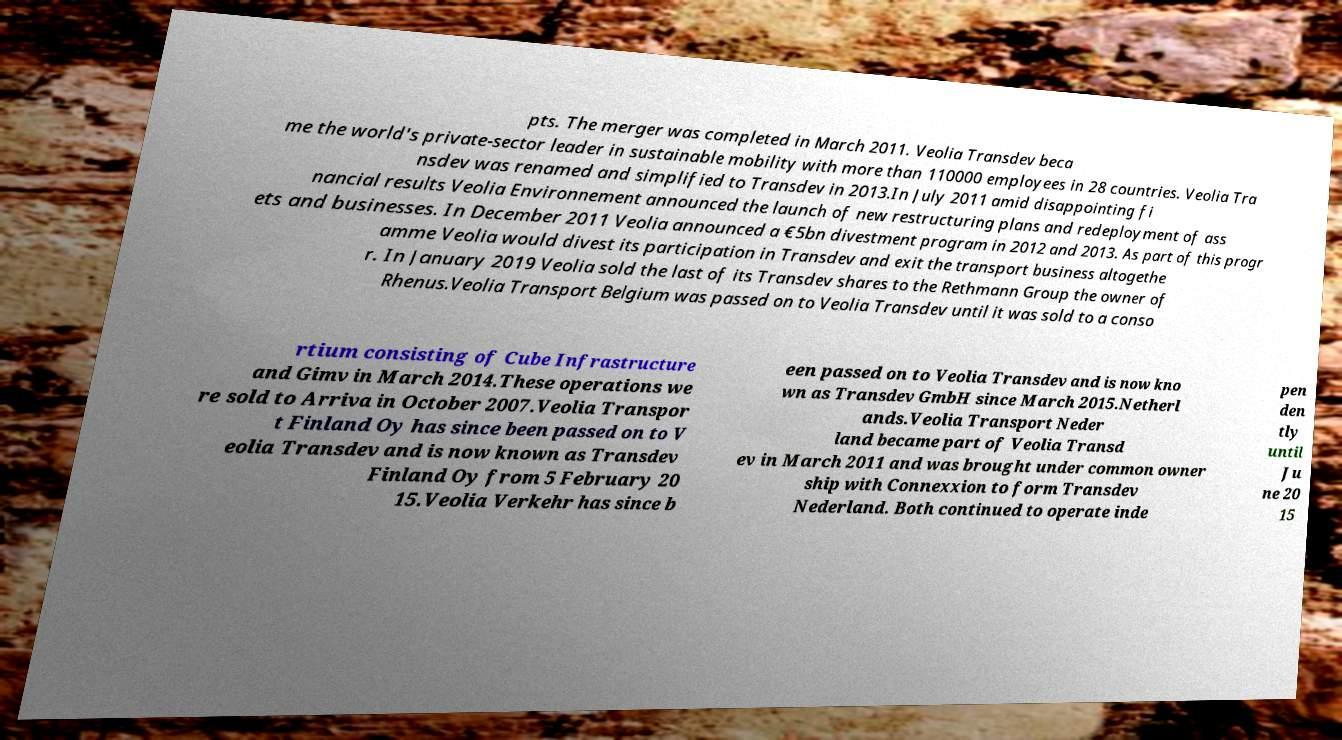Can you accurately transcribe the text from the provided image for me? pts. The merger was completed in March 2011. Veolia Transdev beca me the world's private-sector leader in sustainable mobility with more than 110000 employees in 28 countries. Veolia Tra nsdev was renamed and simplified to Transdev in 2013.In July 2011 amid disappointing fi nancial results Veolia Environnement announced the launch of new restructuring plans and redeployment of ass ets and businesses. In December 2011 Veolia announced a €5bn divestment program in 2012 and 2013. As part of this progr amme Veolia would divest its participation in Transdev and exit the transport business altogethe r. In January 2019 Veolia sold the last of its Transdev shares to the Rethmann Group the owner of Rhenus.Veolia Transport Belgium was passed on to Veolia Transdev until it was sold to a conso rtium consisting of Cube Infrastructure and Gimv in March 2014.These operations we re sold to Arriva in October 2007.Veolia Transpor t Finland Oy has since been passed on to V eolia Transdev and is now known as Transdev Finland Oy from 5 February 20 15.Veolia Verkehr has since b een passed on to Veolia Transdev and is now kno wn as Transdev GmbH since March 2015.Netherl ands.Veolia Transport Neder land became part of Veolia Transd ev in March 2011 and was brought under common owner ship with Connexxion to form Transdev Nederland. Both continued to operate inde pen den tly until Ju ne 20 15 